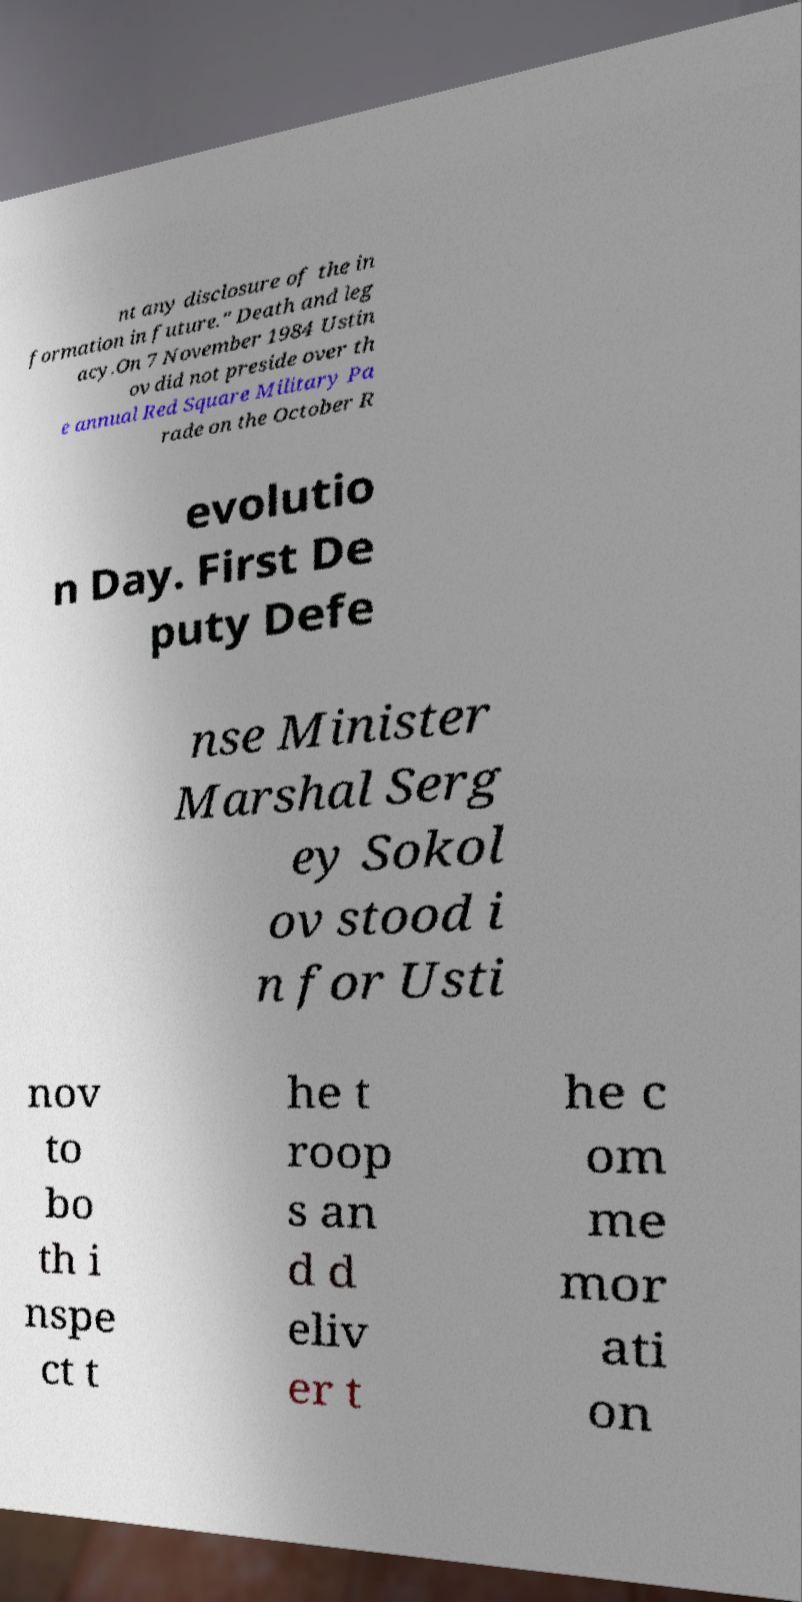There's text embedded in this image that I need extracted. Can you transcribe it verbatim? nt any disclosure of the in formation in future." Death and leg acy.On 7 November 1984 Ustin ov did not preside over th e annual Red Square Military Pa rade on the October R evolutio n Day. First De puty Defe nse Minister Marshal Serg ey Sokol ov stood i n for Usti nov to bo th i nspe ct t he t roop s an d d eliv er t he c om me mor ati on 